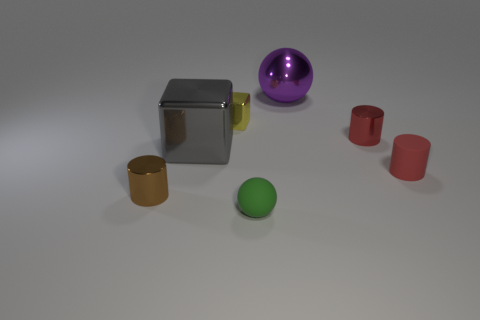Are there any shadows present that might tell us about the lighting in the scene? Yes, there are subtle shadows cast directly underneath and to the side of each object, which suggest an overhead light source, likely diffused to minimize harshness. The shadows help in defining the spatial relation among the objects, hinting at a single, consistent light source within the environment. 